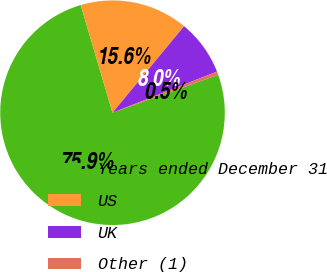Convert chart. <chart><loc_0><loc_0><loc_500><loc_500><pie_chart><fcel>Years ended December 31<fcel>US<fcel>UK<fcel>Other (1)<nl><fcel>75.9%<fcel>15.57%<fcel>8.03%<fcel>0.49%<nl></chart> 